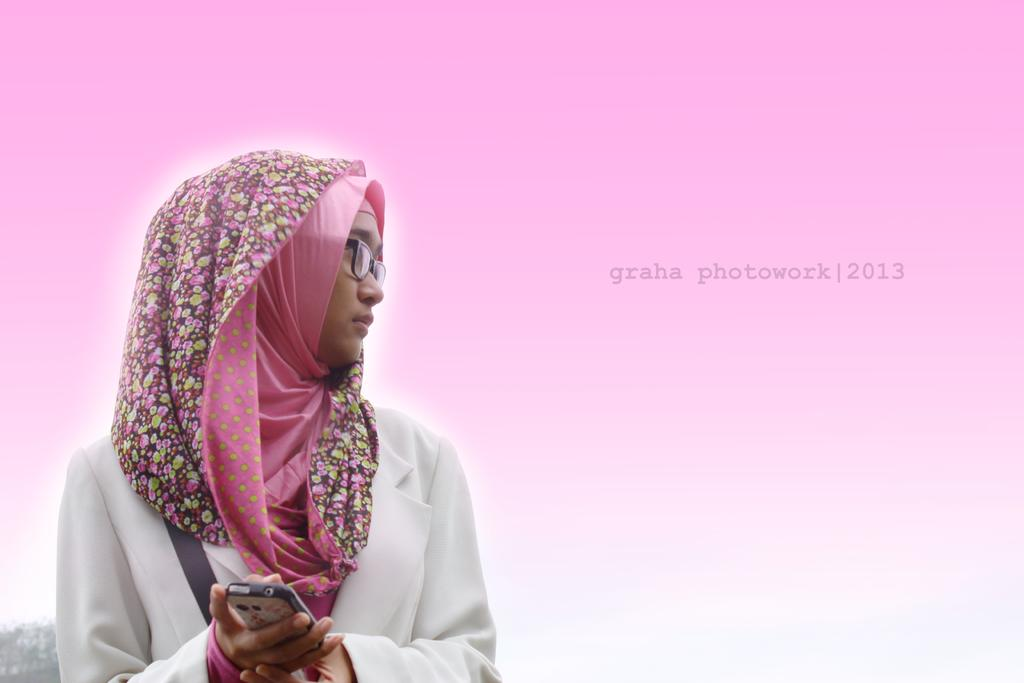Who is the main subject in the image? There is a woman in the image. What is the woman wearing? The woman is wearing a white dress and a pink scarf on her head. What is the woman holding in her hand? The woman is holding a mobile in her hand. In which direction is the woman looking? The woman is looking at the right side of the image. What type of bait is the woman using to catch fish in the image? There is no indication of fishing or bait in the image; the woman is holding a mobile and looking at the right side of the image. 